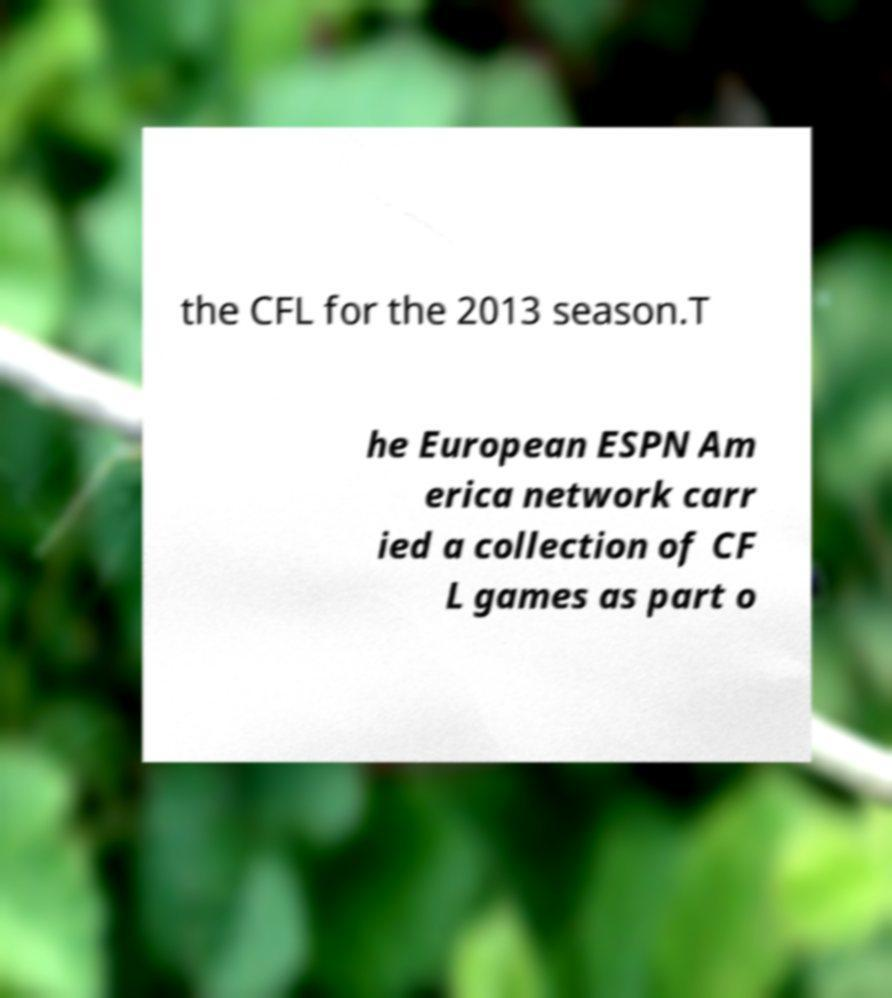Could you extract and type out the text from this image? the CFL for the 2013 season.T he European ESPN Am erica network carr ied a collection of CF L games as part o 